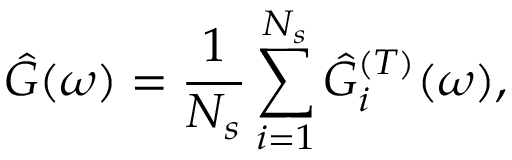Convert formula to latex. <formula><loc_0><loc_0><loc_500><loc_500>\hat { G } ( \omega ) = \frac { 1 } { N _ { s } } \sum _ { i = 1 } ^ { N _ { s } } \hat { G } _ { i } ^ { ( T ) } ( \omega ) ,</formula> 